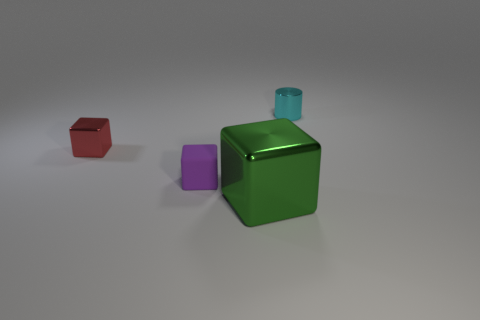Is there anything else that has the same size as the green thing?
Provide a short and direct response. No. Are there any tiny cyan shiny things in front of the tiny shiny object that is in front of the object behind the red thing?
Offer a terse response. No. What number of other things are made of the same material as the tiny purple object?
Give a very brief answer. 0. What number of big brown balls are there?
Give a very brief answer. 0. How many things are small blocks or blocks in front of the small metal cube?
Your answer should be compact. 3. Is there anything else that is the same shape as the big metal object?
Offer a very short reply. Yes. There is a object that is left of the purple rubber cube; does it have the same size as the tiny purple object?
Give a very brief answer. Yes. How many matte objects are either yellow blocks or tiny cyan cylinders?
Your answer should be compact. 0. There is a metallic cube in front of the red metal object; how big is it?
Give a very brief answer. Large. Is the shape of the red object the same as the large shiny thing?
Your response must be concise. Yes. 